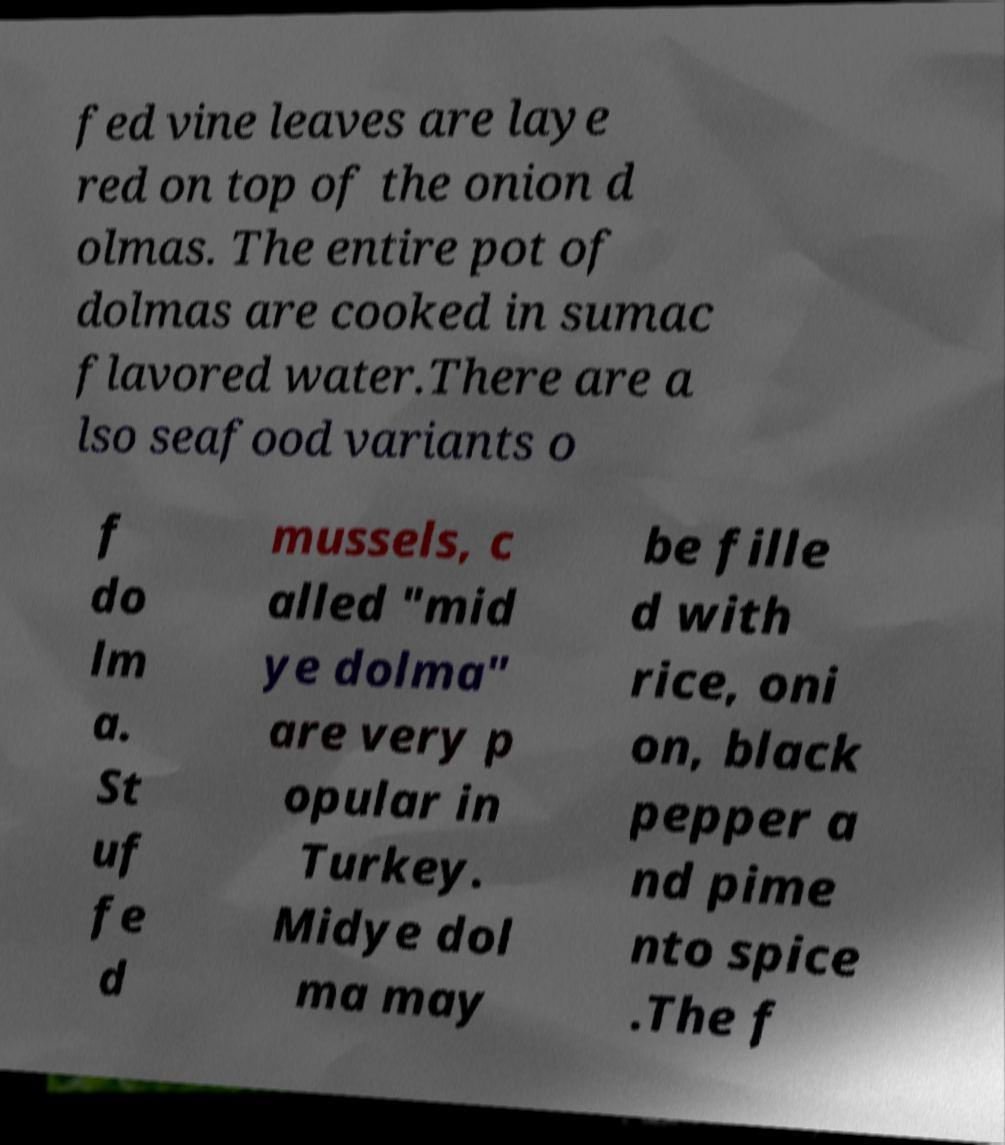I need the written content from this picture converted into text. Can you do that? fed vine leaves are laye red on top of the onion d olmas. The entire pot of dolmas are cooked in sumac flavored water.There are a lso seafood variants o f do lm a. St uf fe d mussels, c alled "mid ye dolma" are very p opular in Turkey. Midye dol ma may be fille d with rice, oni on, black pepper a nd pime nto spice .The f 